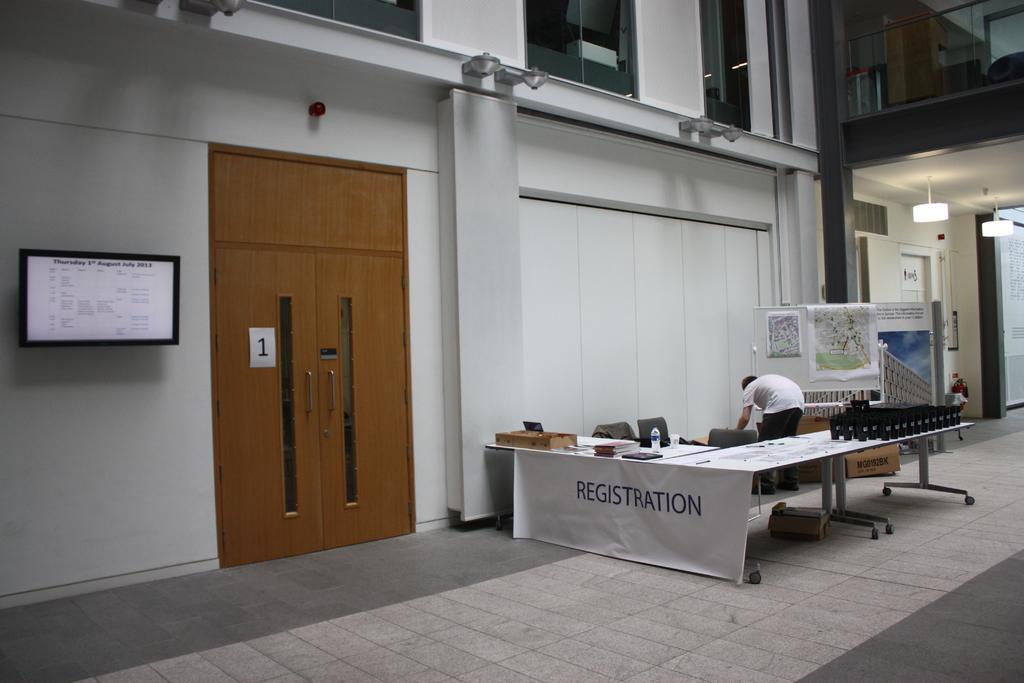Describe this image in one or two sentences. In this picture we can see a man standing, chairs, bottle, banner, posters on a board, doors, television, lights, table, wall, glass, floor, sticker and some objects. 